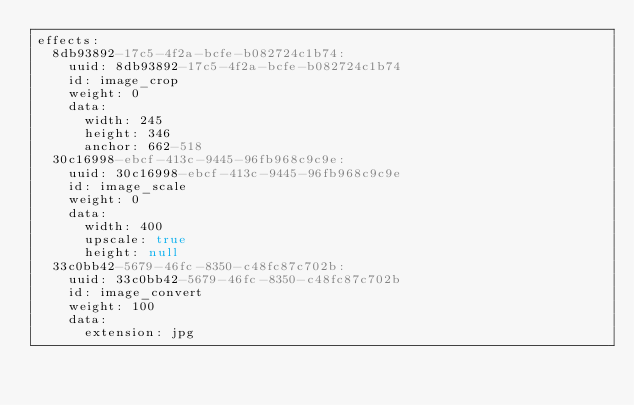<code> <loc_0><loc_0><loc_500><loc_500><_YAML_>effects:
  8db93892-17c5-4f2a-bcfe-b082724c1b74:
    uuid: 8db93892-17c5-4f2a-bcfe-b082724c1b74
    id: image_crop
    weight: 0
    data:
      width: 245
      height: 346
      anchor: 662-518
  30c16998-ebcf-413c-9445-96fb968c9c9e:
    uuid: 30c16998-ebcf-413c-9445-96fb968c9c9e
    id: image_scale
    weight: 0
    data:
      width: 400
      upscale: true
      height: null
  33c0bb42-5679-46fc-8350-c48fc87c702b:
    uuid: 33c0bb42-5679-46fc-8350-c48fc87c702b
    id: image_convert
    weight: 100
    data:
      extension: jpg
</code> 